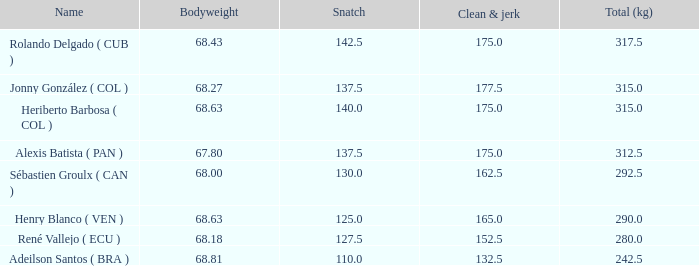63 bodyweight and a total kg under 290? None. 